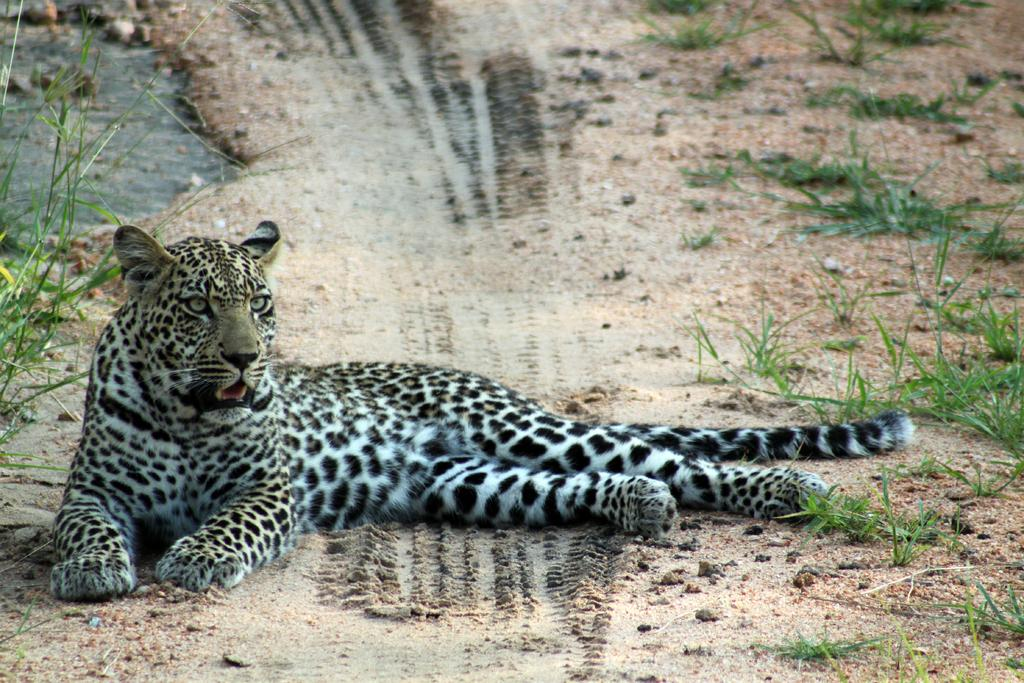What animal can be seen in the image? There is a leopard in the image. What is the leopard doing in the image? The leopard is laying on the ground. What type of vegetation is present in the image? There is grass and plants in the image. Where is the hospital located in the image? There is no hospital present in the image; it features a leopard laying on the ground in a natural setting with grass and plants. 